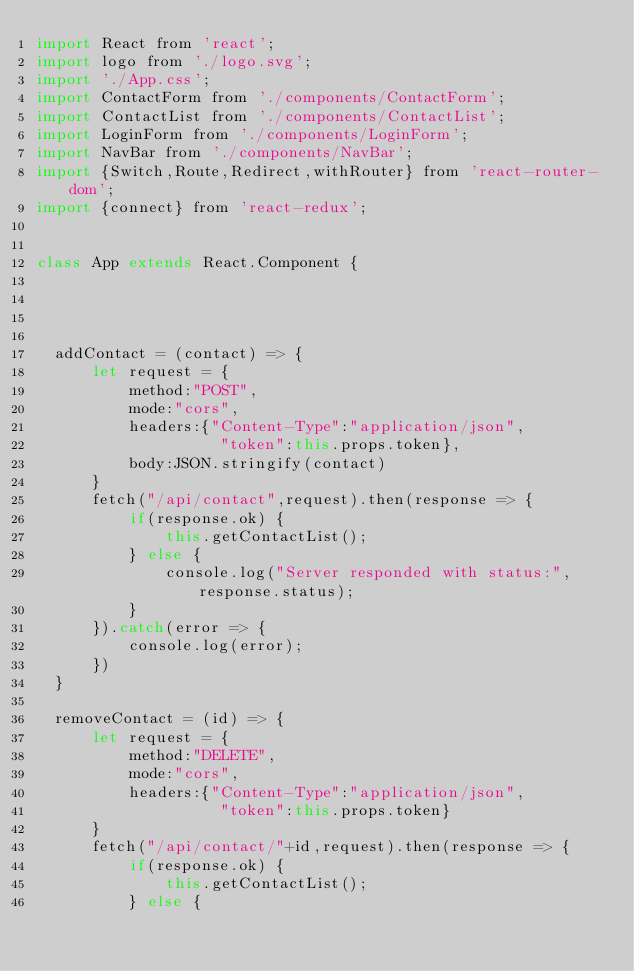<code> <loc_0><loc_0><loc_500><loc_500><_JavaScript_>import React from 'react';
import logo from './logo.svg';
import './App.css';
import ContactForm from './components/ContactForm';
import ContactList from './components/ContactList';
import LoginForm from './components/LoginForm';
import NavBar from './components/NavBar';
import {Switch,Route,Redirect,withRouter} from 'react-router-dom';
import {connect} from 'react-redux';


class App extends React.Component {
  


  
  addContact = (contact) => {
	  let request = {
		  method:"POST",
		  mode:"cors",
		  headers:{"Content-Type":"application/json",
					"token":this.props.token},
		  body:JSON.stringify(contact)
	  }
	  fetch("/api/contact",request).then(response => {
		  if(response.ok) {
			  this.getContactList();
		  } else {
			  console.log("Server responded with status:",response.status);
		  }
	  }).catch(error => {
		  console.log(error);
	  })
  }
  
  removeContact = (id) => {
	  let request = {
		  method:"DELETE",
		  mode:"cors",
		  headers:{"Content-Type":"application/json",
					"token":this.props.token}
	  }
	  fetch("/api/contact/"+id,request).then(response => {
		  if(response.ok) {
			  this.getContactList();
		  } else {</code> 